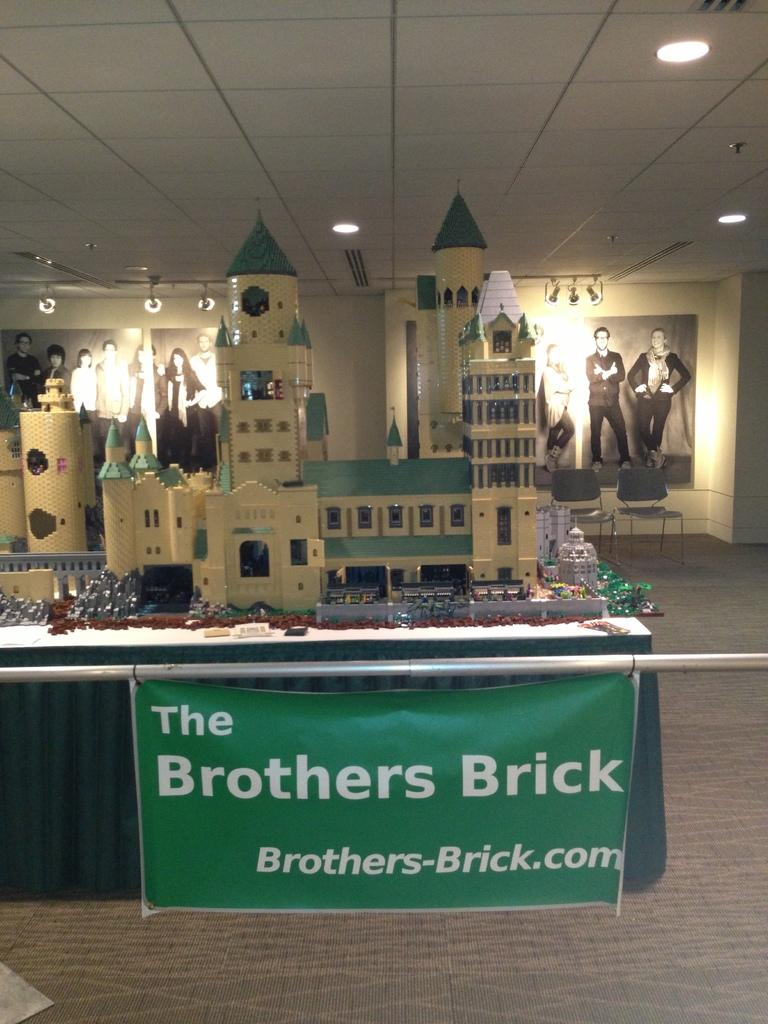Provide a one-sentence caption for the provided image. A replica of a castle sits behind a sign that says The Brothers Brick. 